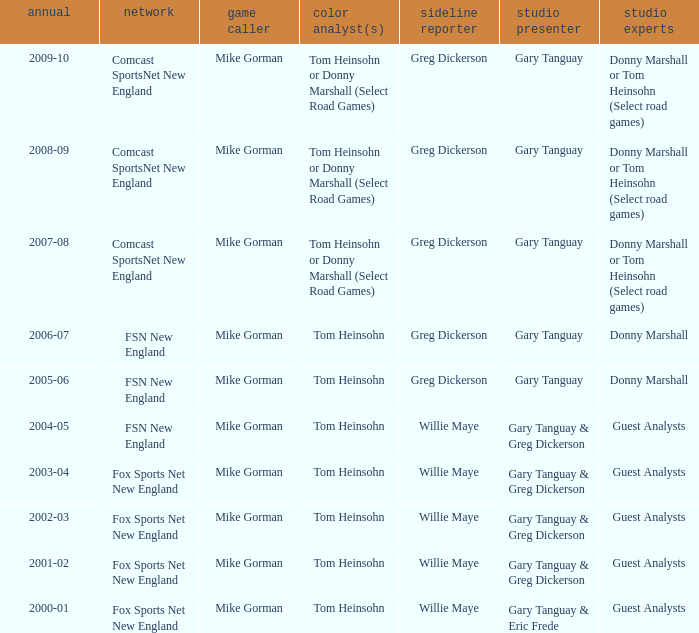Parse the table in full. {'header': ['annual', 'network', 'game caller', 'color analyst(s)', 'sideline reporter', 'studio presenter', 'studio experts'], 'rows': [['2009-10', 'Comcast SportsNet New England', 'Mike Gorman', 'Tom Heinsohn or Donny Marshall (Select Road Games)', 'Greg Dickerson', 'Gary Tanguay', 'Donny Marshall or Tom Heinsohn (Select road games)'], ['2008-09', 'Comcast SportsNet New England', 'Mike Gorman', 'Tom Heinsohn or Donny Marshall (Select Road Games)', 'Greg Dickerson', 'Gary Tanguay', 'Donny Marshall or Tom Heinsohn (Select road games)'], ['2007-08', 'Comcast SportsNet New England', 'Mike Gorman', 'Tom Heinsohn or Donny Marshall (Select Road Games)', 'Greg Dickerson', 'Gary Tanguay', 'Donny Marshall or Tom Heinsohn (Select road games)'], ['2006-07', 'FSN New England', 'Mike Gorman', 'Tom Heinsohn', 'Greg Dickerson', 'Gary Tanguay', 'Donny Marshall'], ['2005-06', 'FSN New England', 'Mike Gorman', 'Tom Heinsohn', 'Greg Dickerson', 'Gary Tanguay', 'Donny Marshall'], ['2004-05', 'FSN New England', 'Mike Gorman', 'Tom Heinsohn', 'Willie Maye', 'Gary Tanguay & Greg Dickerson', 'Guest Analysts'], ['2003-04', 'Fox Sports Net New England', 'Mike Gorman', 'Tom Heinsohn', 'Willie Maye', 'Gary Tanguay & Greg Dickerson', 'Guest Analysts'], ['2002-03', 'Fox Sports Net New England', 'Mike Gorman', 'Tom Heinsohn', 'Willie Maye', 'Gary Tanguay & Greg Dickerson', 'Guest Analysts'], ['2001-02', 'Fox Sports Net New England', 'Mike Gorman', 'Tom Heinsohn', 'Willie Maye', 'Gary Tanguay & Greg Dickerson', 'Guest Analysts'], ['2000-01', 'Fox Sports Net New England', 'Mike Gorman', 'Tom Heinsohn', 'Willie Maye', 'Gary Tanguay & Eric Frede', 'Guest Analysts']]} WHich Studio host has a Year of 2003-04? Gary Tanguay & Greg Dickerson. 